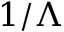Convert formula to latex. <formula><loc_0><loc_0><loc_500><loc_500>1 / \Lambda</formula> 